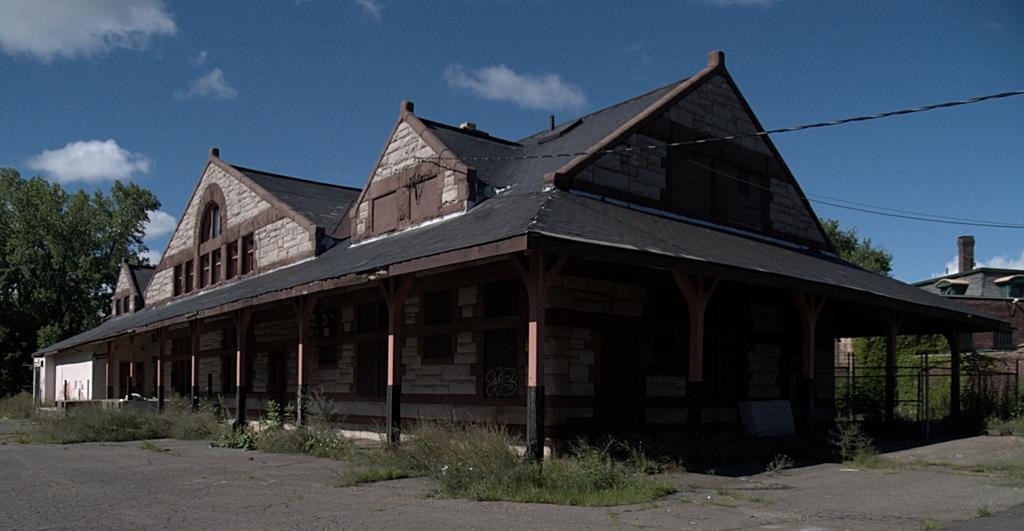What type of structures can be seen in the image? There are buildings in the image. What objects are present for cooking purposes? There are grills in the image. What type of barriers are visible in the image? There are fences in the image. What type of wiring or connections can be seen in the image? There are cables in the image. What type of vegetation is present in the image? There are trees in the image. What is visible in the background of the image? The sky is visible in the background of the image. What can be seen in the sky? There are clouds in the sky. What type of drum can be heard playing in the image? There is no drum present in the image, and therefore no sound can be heard. What type of ink is used to write on the buildings in the image? There is no writing or ink visible on the buildings in the image. 